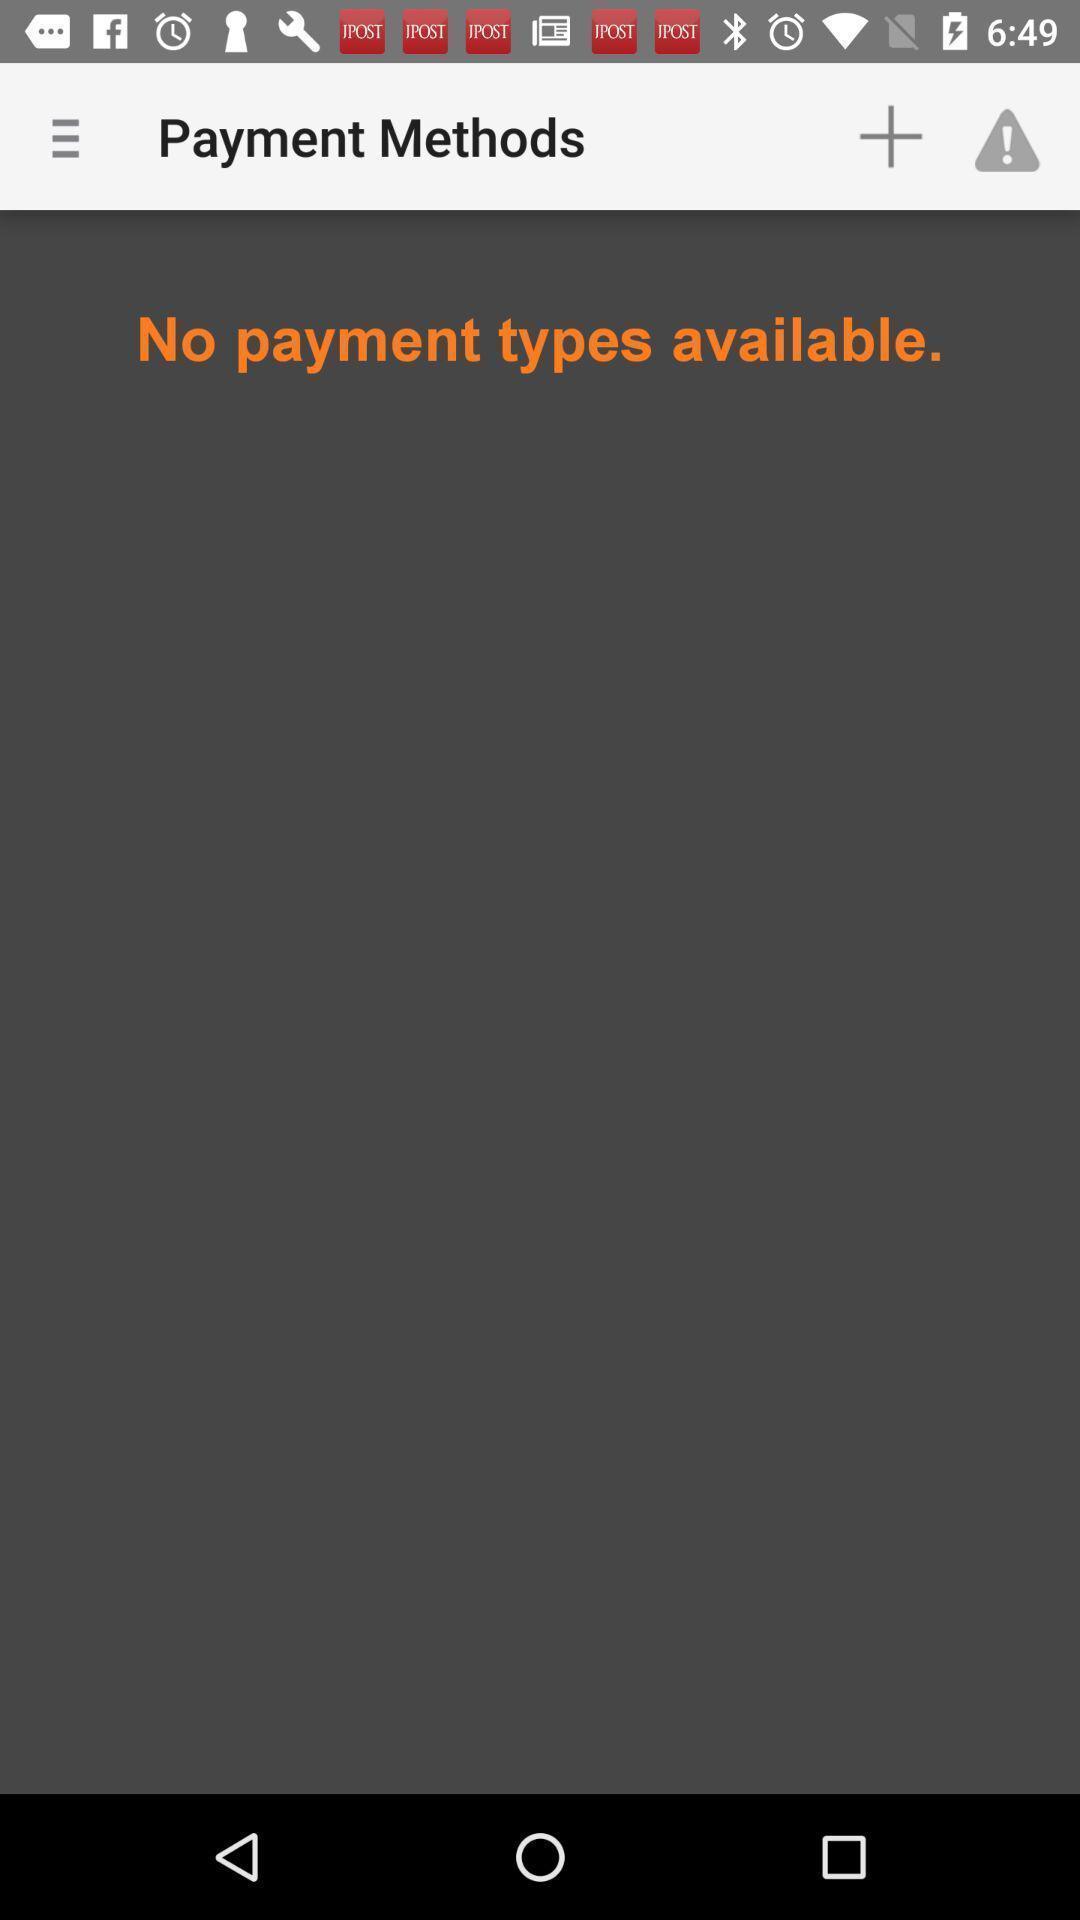What can you discern from this picture? Page showing history. 